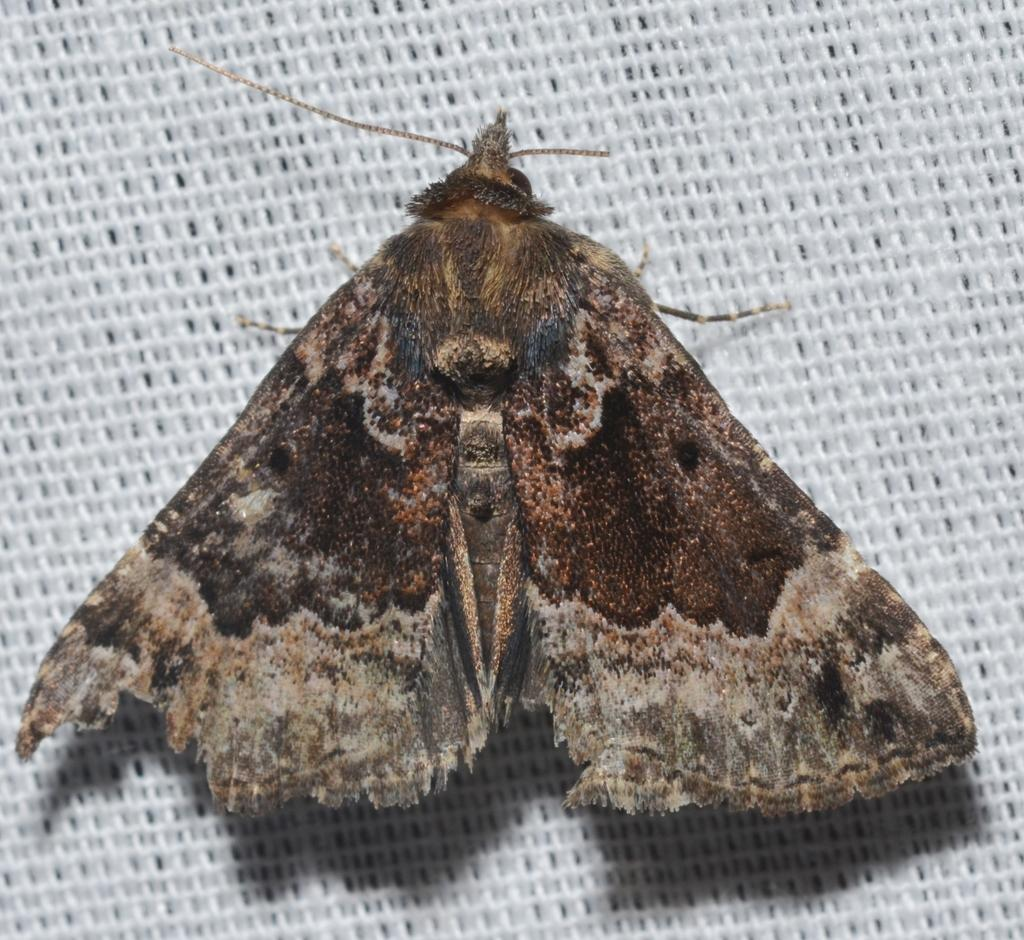What type of creature is present in the picture? There is an insect in the picture. Can you describe the insect's body? The insect has a body, wings, legs, and a head. What is visible in the background of the picture? There is a white surface in the background of the picture. Where is the governor's house located in the image? There is no mention of a governor or a house in the image; it features an insect with a body, wings, legs, and a head against a white background. 